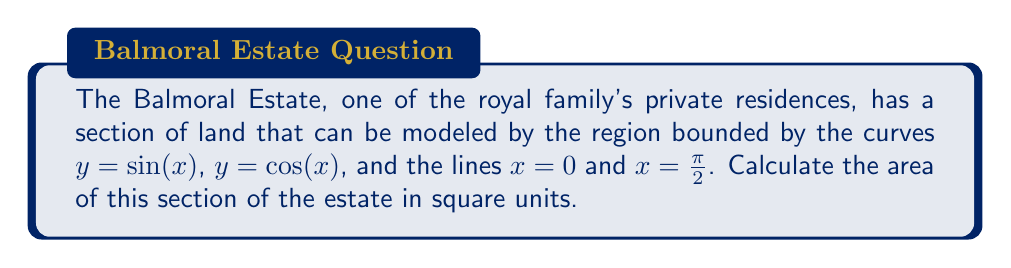Show me your answer to this math problem. To find the area of this region, we need to evaluate the integral of the difference between the two curves over the given interval. Let's approach this step-by-step:

1) The area is given by the integral:

   $$A = \int_0^{\frac{\pi}{2}} [\cos(x) - \sin(x)] dx$$

2) To evaluate this integral, we can use the substitution method:
   Let $u = x$, then $du = dx$

3) Rewrite the integral:

   $$A = \int_0^{\frac{\pi}{2}} \cos(u) du - \int_0^{\frac{\pi}{2}} \sin(u) du$$

4) Evaluate each integral separately:

   $$\int \cos(u) du = \sin(u) + C$$
   $$\int \sin(u) du = -\cos(u) + C$$

5) Apply the limits:

   $$A = [\sin(u)]_0^{\frac{\pi}{2}} - [-\cos(u)]_0^{\frac{\pi}{2}}$$

6) Substitute the limits:

   $$A = [\sin(\frac{\pi}{2}) - \sin(0)] - [-\cos(\frac{\pi}{2}) + \cos(0)]$$

7) Simplify:

   $$A = [1 - 0] - [0 - 1] = 1 + 1 = 2$$

Therefore, the area of this section of the Balmoral Estate is 2 square units.
Answer: 2 square units 